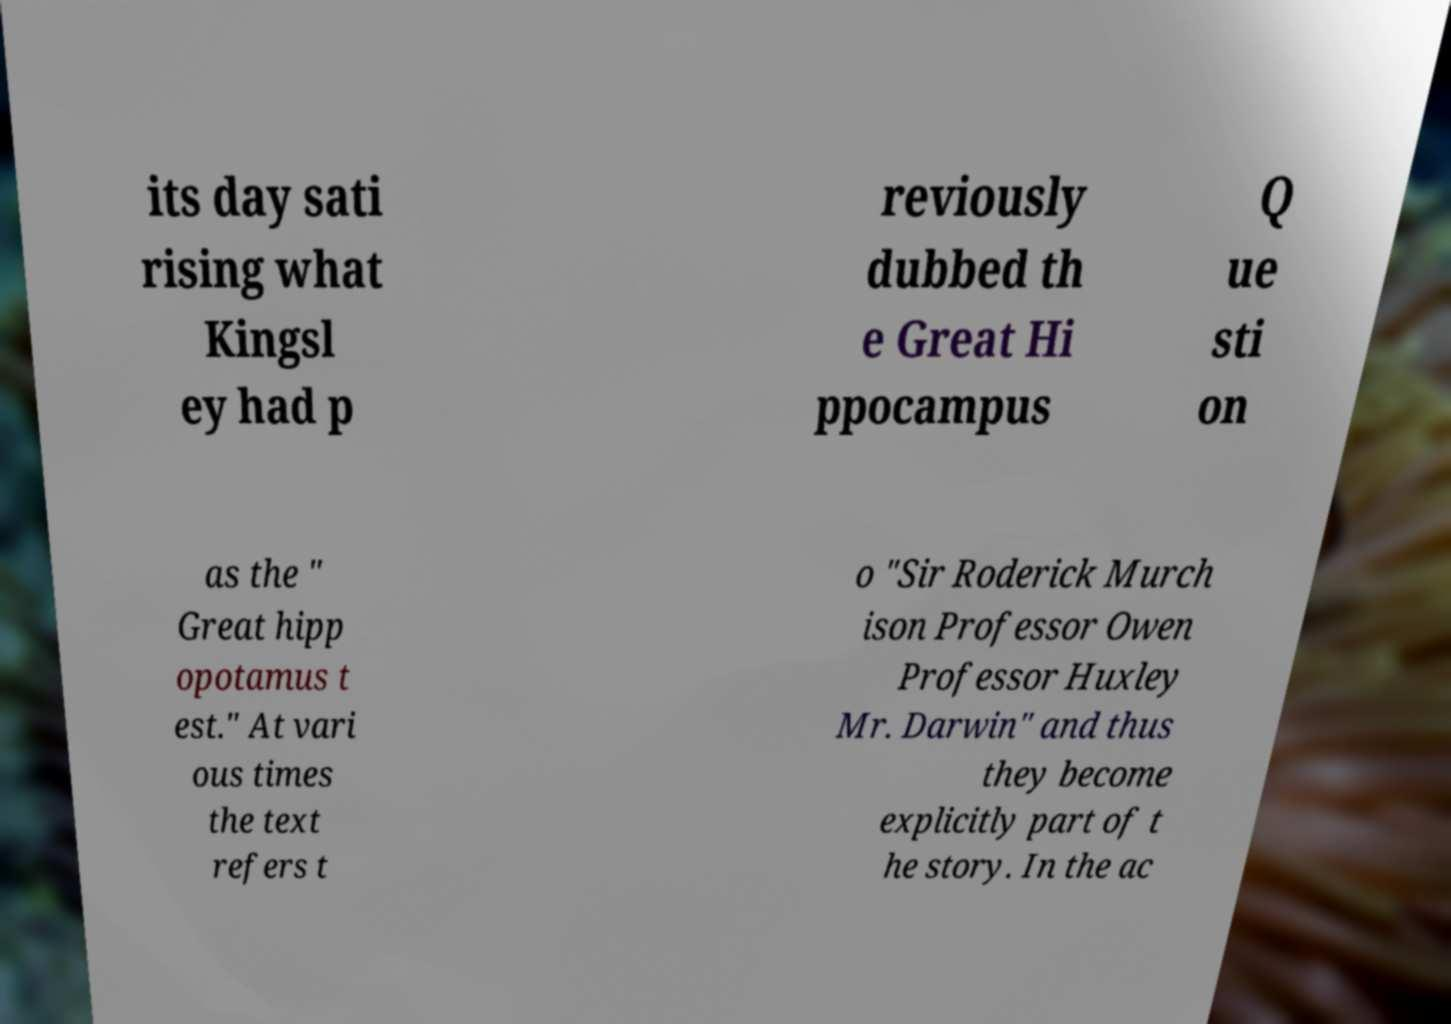I need the written content from this picture converted into text. Can you do that? its day sati rising what Kingsl ey had p reviously dubbed th e Great Hi ppocampus Q ue sti on as the " Great hipp opotamus t est." At vari ous times the text refers t o "Sir Roderick Murch ison Professor Owen Professor Huxley Mr. Darwin" and thus they become explicitly part of t he story. In the ac 